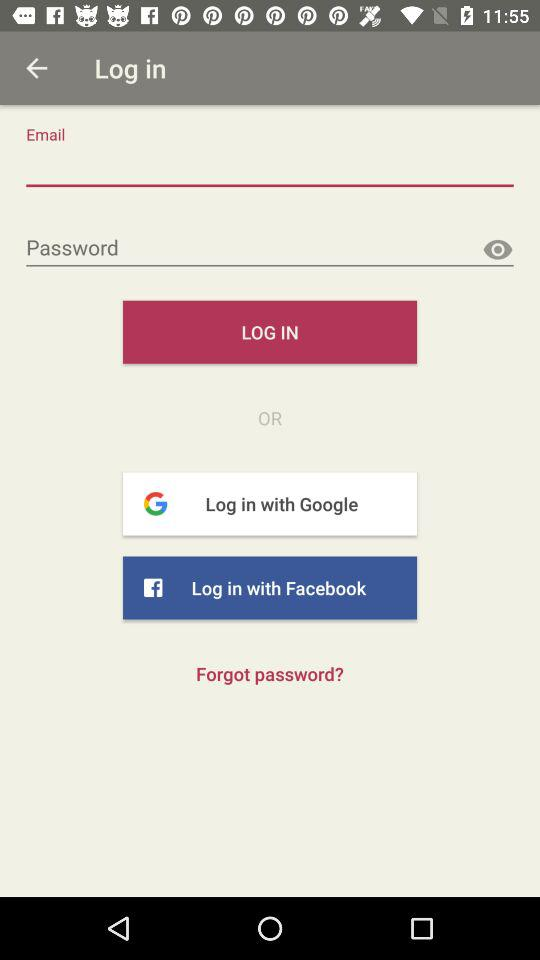What are the requirements to log in? The requirements to log in are "Email" and "Password". 